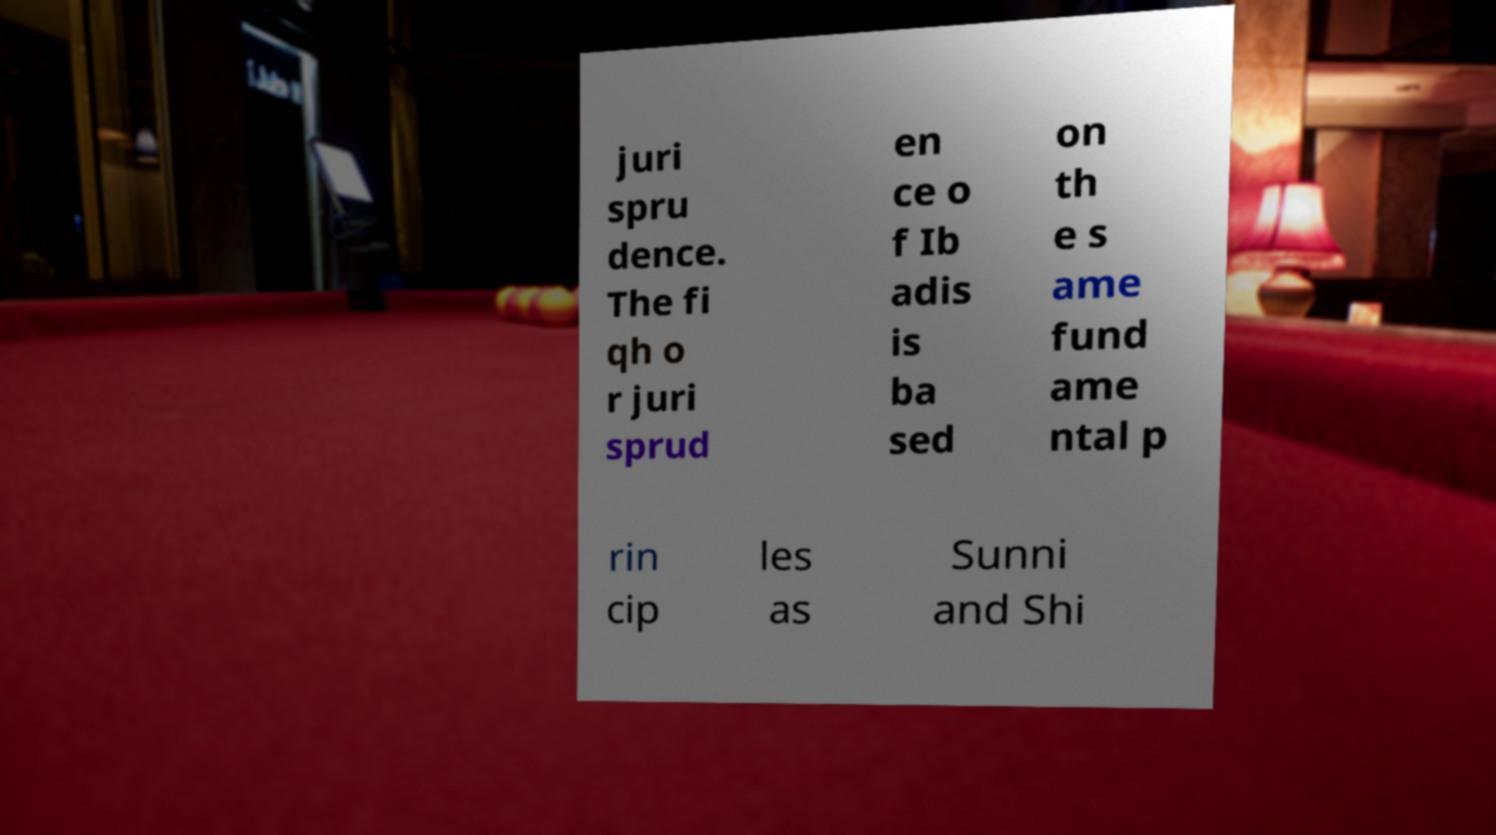What messages or text are displayed in this image? I need them in a readable, typed format. juri spru dence. The fi qh o r juri sprud en ce o f Ib adis is ba sed on th e s ame fund ame ntal p rin cip les as Sunni and Shi 